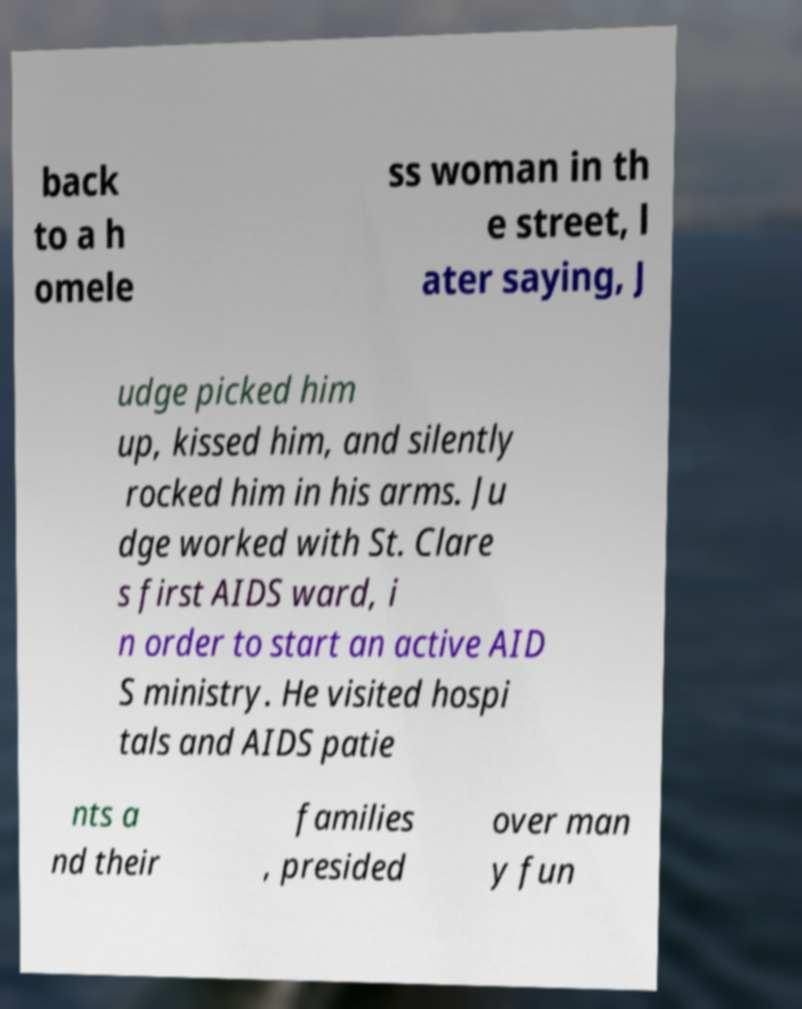Could you assist in decoding the text presented in this image and type it out clearly? back to a h omele ss woman in th e street, l ater saying, J udge picked him up, kissed him, and silently rocked him in his arms. Ju dge worked with St. Clare s first AIDS ward, i n order to start an active AID S ministry. He visited hospi tals and AIDS patie nts a nd their families , presided over man y fun 